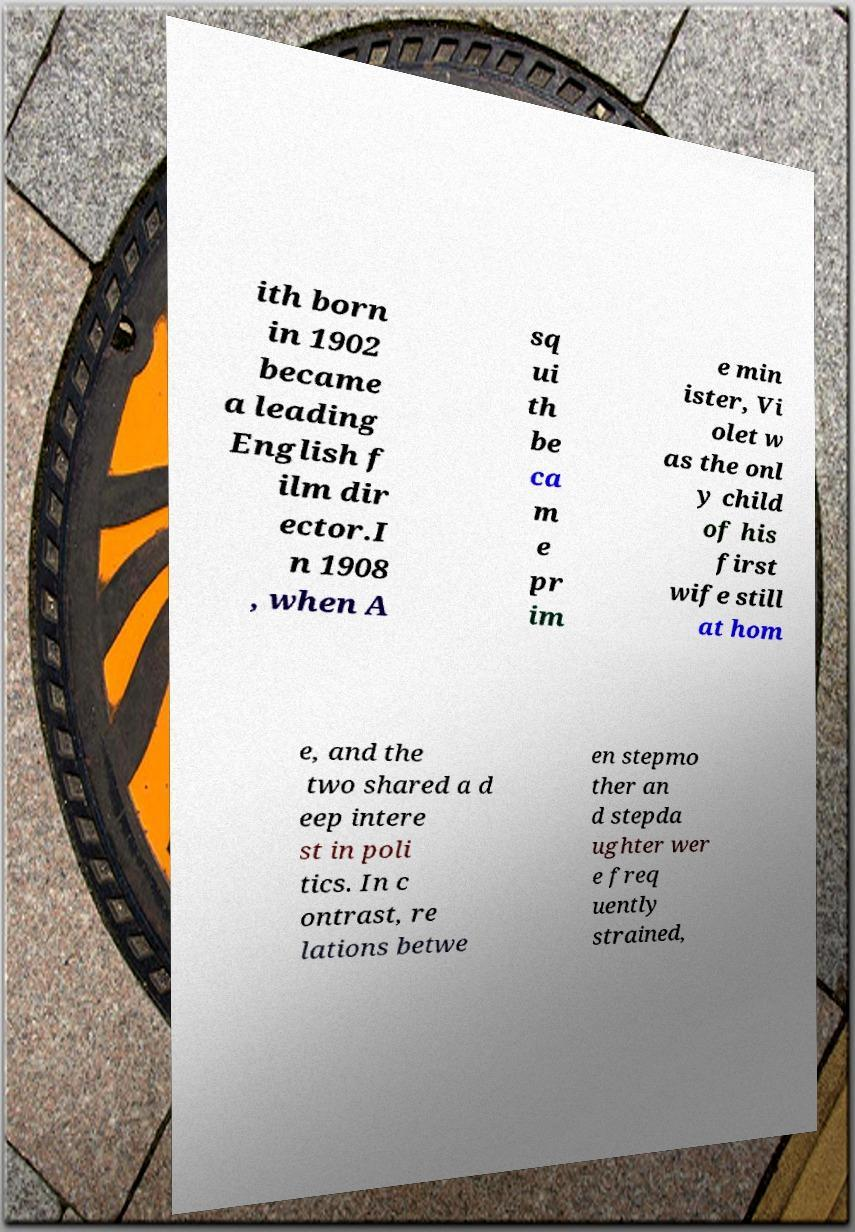Please read and relay the text visible in this image. What does it say? ith born in 1902 became a leading English f ilm dir ector.I n 1908 , when A sq ui th be ca m e pr im e min ister, Vi olet w as the onl y child of his first wife still at hom e, and the two shared a d eep intere st in poli tics. In c ontrast, re lations betwe en stepmo ther an d stepda ughter wer e freq uently strained, 